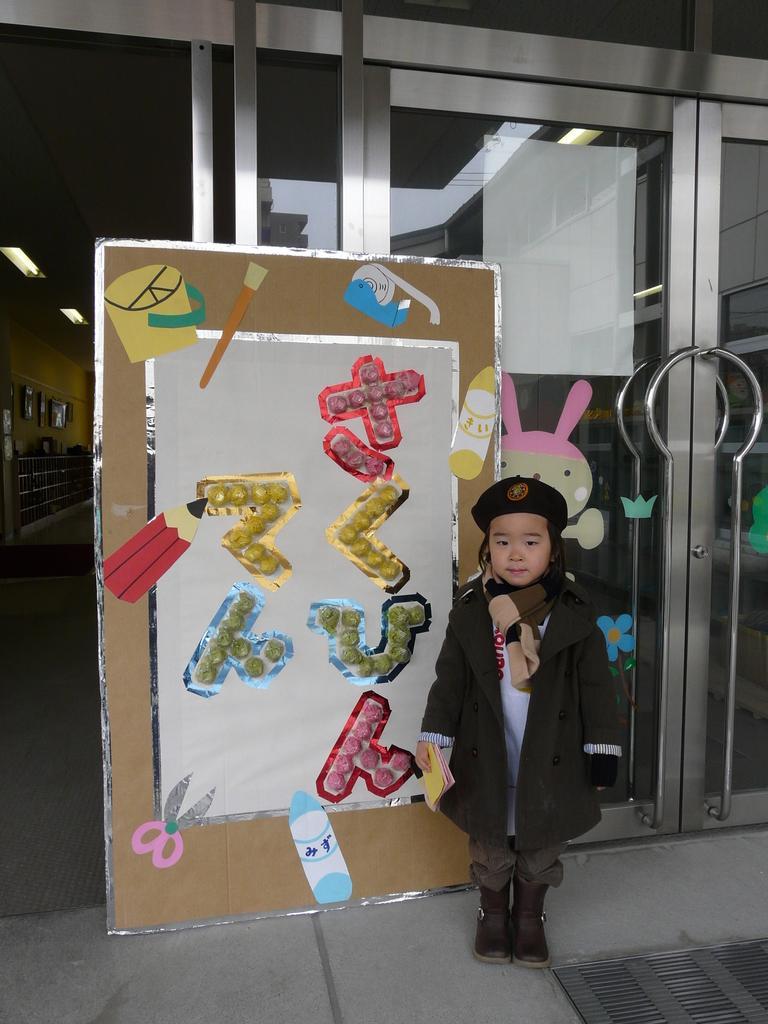Please provide a concise description of this image. In this image there is a kid standing on the floor having a board. On the board there is some painting. Left side few frames are attached to the wall. Few lights are attached to the roof. Few objects are on the floor. The kid is wearing a cap. He is holding few papers in his hand. 